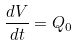Convert formula to latex. <formula><loc_0><loc_0><loc_500><loc_500>\frac { d V } { d t } = Q _ { 0 }</formula> 